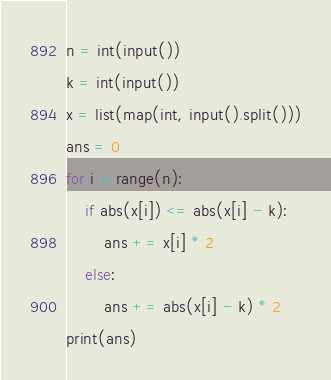Convert code to text. <code><loc_0><loc_0><loc_500><loc_500><_Python_>n = int(input())
k = int(input())
x = list(map(int, input().split()))
ans = 0
for i in range(n):
    if abs(x[i]) <= abs(x[i] - k):
        ans += x[i] * 2
    else:
        ans += abs(x[i] - k) * 2
print(ans)</code> 